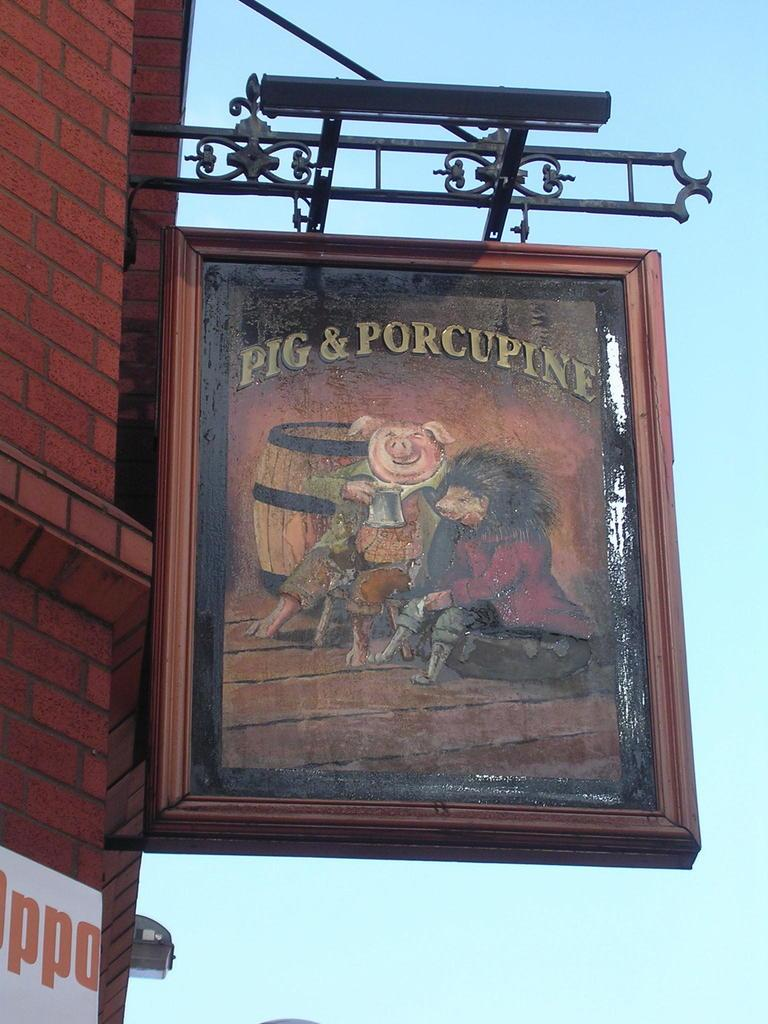What is on the wall in the image? There is a board on the wall in the image. What is on the board? There is a painting on the board. What can be seen in the background of the image? The sky is visible in the background of the image. What type of soap is being used to clean the painting in the image? There is no soap or cleaning activity present in the image; it features a board with a painting on it and a visible sky in the background. 